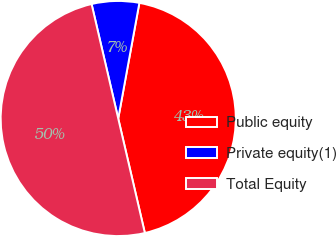Convert chart. <chart><loc_0><loc_0><loc_500><loc_500><pie_chart><fcel>Public equity<fcel>Private equity(1)<fcel>Total Equity<nl><fcel>43.48%<fcel>6.52%<fcel>50.0%<nl></chart> 